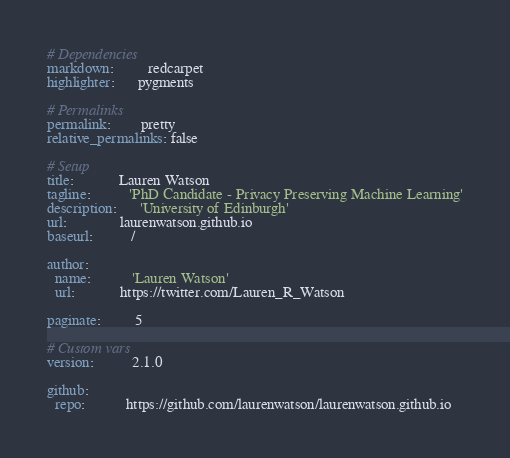Convert code to text. <code><loc_0><loc_0><loc_500><loc_500><_YAML_># Dependencies
markdown:         redcarpet
highlighter:      pygments

# Permalinks
permalink:        pretty
relative_permalinks: false

# Setup
title:            Lauren Watson
tagline:          'PhD Candidate - Privacy Preserving Machine Learning'
description:      'University of Edinburgh'
url:              laurenwatson.github.io
baseurl:          /

author:
  name:           'Lauren Watson'
  url:            https://twitter.com/Lauren_R_Watson

paginate:         5

# Custom vars
version:          2.1.0

github:
  repo:           https://github.com/laurenwatson/laurenwatson.github.io
</code> 